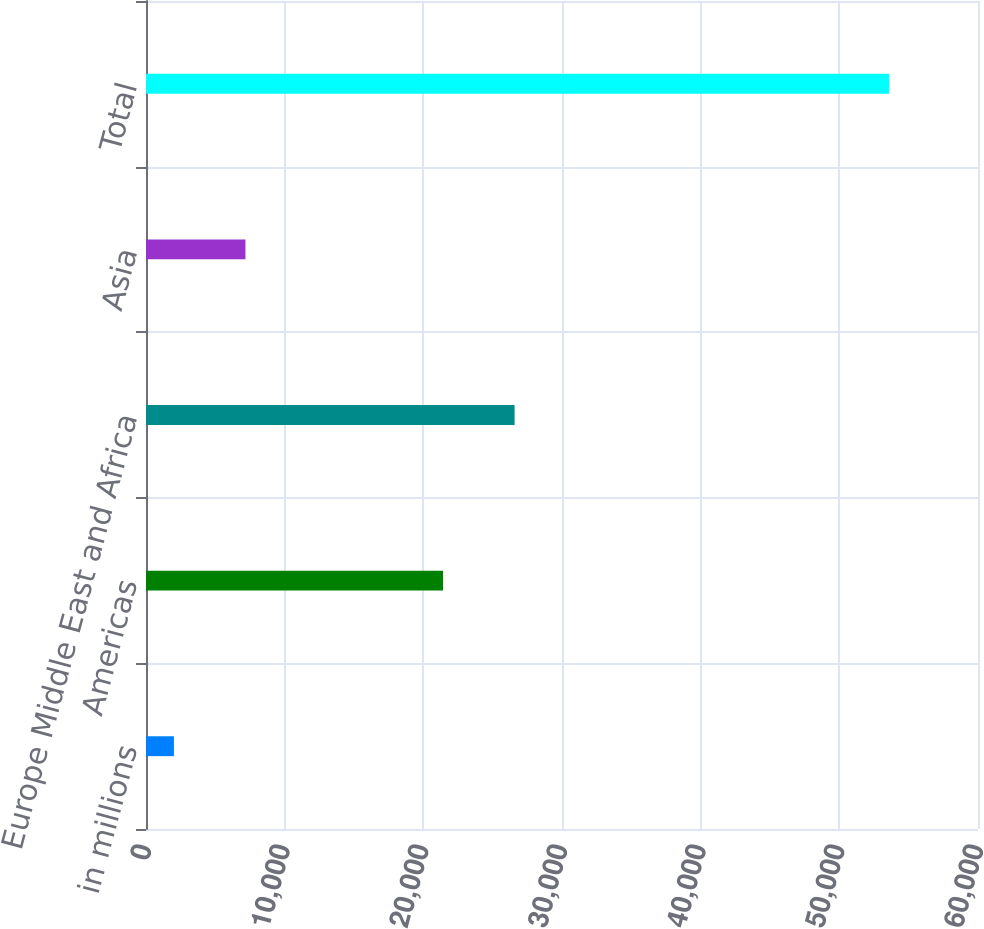<chart> <loc_0><loc_0><loc_500><loc_500><bar_chart><fcel>in millions<fcel>Americas<fcel>Europe Middle East and Africa<fcel>Asia<fcel>Total<nl><fcel>2013<fcel>21423<fcel>26581.9<fcel>7171.9<fcel>53602<nl></chart> 